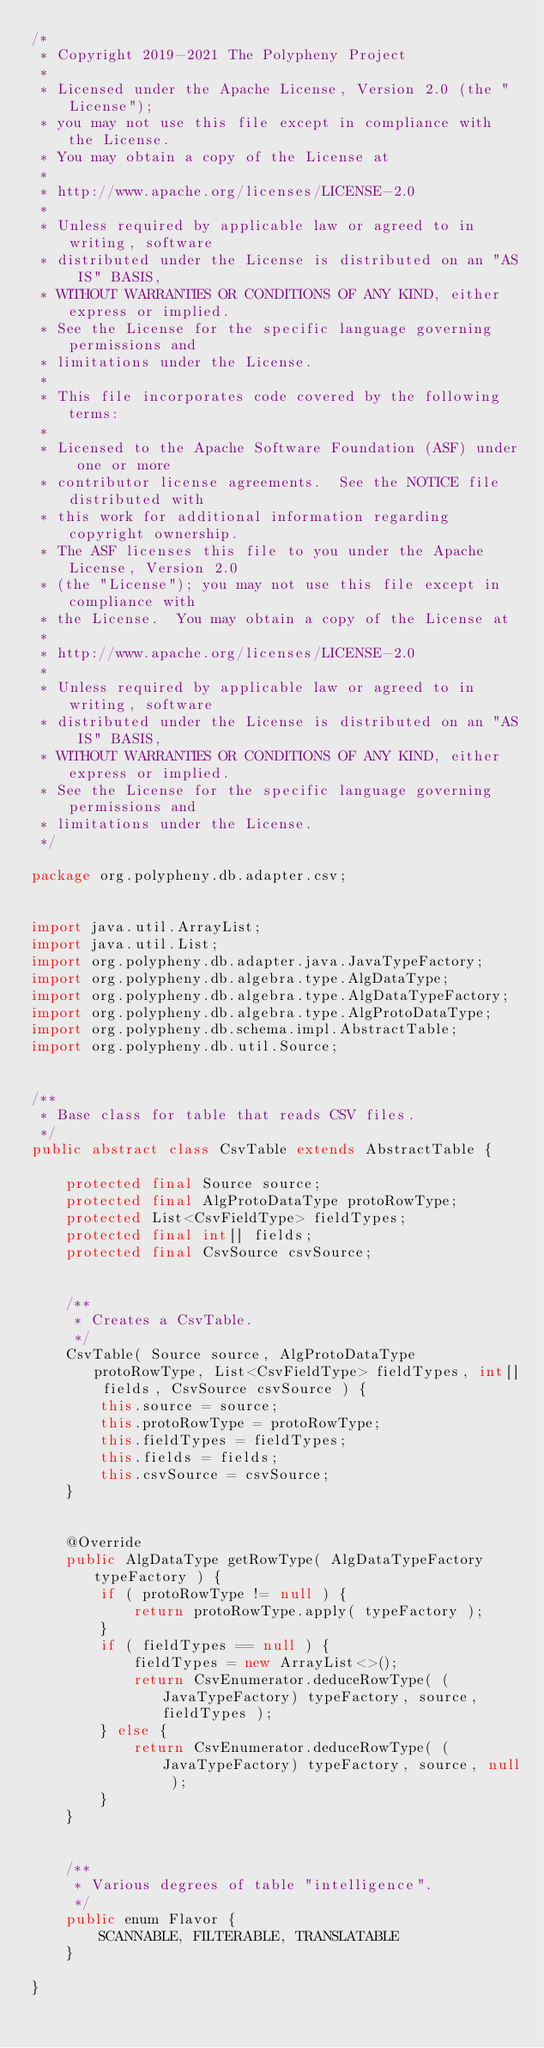Convert code to text. <code><loc_0><loc_0><loc_500><loc_500><_Java_>/*
 * Copyright 2019-2021 The Polypheny Project
 *
 * Licensed under the Apache License, Version 2.0 (the "License");
 * you may not use this file except in compliance with the License.
 * You may obtain a copy of the License at
 *
 * http://www.apache.org/licenses/LICENSE-2.0
 *
 * Unless required by applicable law or agreed to in writing, software
 * distributed under the License is distributed on an "AS IS" BASIS,
 * WITHOUT WARRANTIES OR CONDITIONS OF ANY KIND, either express or implied.
 * See the License for the specific language governing permissions and
 * limitations under the License.
 *
 * This file incorporates code covered by the following terms:
 *
 * Licensed to the Apache Software Foundation (ASF) under one or more
 * contributor license agreements.  See the NOTICE file distributed with
 * this work for additional information regarding copyright ownership.
 * The ASF licenses this file to you under the Apache License, Version 2.0
 * (the "License"); you may not use this file except in compliance with
 * the License.  You may obtain a copy of the License at
 *
 * http://www.apache.org/licenses/LICENSE-2.0
 *
 * Unless required by applicable law or agreed to in writing, software
 * distributed under the License is distributed on an "AS IS" BASIS,
 * WITHOUT WARRANTIES OR CONDITIONS OF ANY KIND, either express or implied.
 * See the License for the specific language governing permissions and
 * limitations under the License.
 */

package org.polypheny.db.adapter.csv;


import java.util.ArrayList;
import java.util.List;
import org.polypheny.db.adapter.java.JavaTypeFactory;
import org.polypheny.db.algebra.type.AlgDataType;
import org.polypheny.db.algebra.type.AlgDataTypeFactory;
import org.polypheny.db.algebra.type.AlgProtoDataType;
import org.polypheny.db.schema.impl.AbstractTable;
import org.polypheny.db.util.Source;


/**
 * Base class for table that reads CSV files.
 */
public abstract class CsvTable extends AbstractTable {

    protected final Source source;
    protected final AlgProtoDataType protoRowType;
    protected List<CsvFieldType> fieldTypes;
    protected final int[] fields;
    protected final CsvSource csvSource;


    /**
     * Creates a CsvTable.
     */
    CsvTable( Source source, AlgProtoDataType protoRowType, List<CsvFieldType> fieldTypes, int[] fields, CsvSource csvSource ) {
        this.source = source;
        this.protoRowType = protoRowType;
        this.fieldTypes = fieldTypes;
        this.fields = fields;
        this.csvSource = csvSource;
    }


    @Override
    public AlgDataType getRowType( AlgDataTypeFactory typeFactory ) {
        if ( protoRowType != null ) {
            return protoRowType.apply( typeFactory );
        }
        if ( fieldTypes == null ) {
            fieldTypes = new ArrayList<>();
            return CsvEnumerator.deduceRowType( (JavaTypeFactory) typeFactory, source, fieldTypes );
        } else {
            return CsvEnumerator.deduceRowType( (JavaTypeFactory) typeFactory, source, null );
        }
    }


    /**
     * Various degrees of table "intelligence".
     */
    public enum Flavor {
        SCANNABLE, FILTERABLE, TRANSLATABLE
    }

}

</code> 